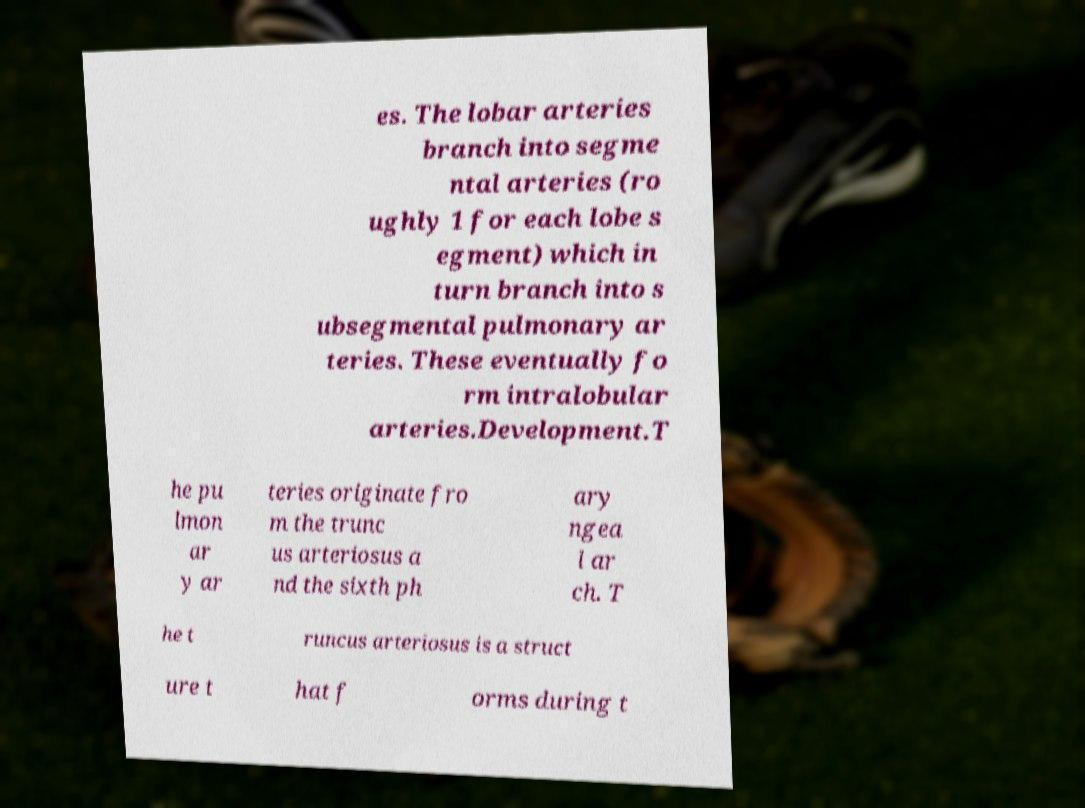Could you extract and type out the text from this image? es. The lobar arteries branch into segme ntal arteries (ro ughly 1 for each lobe s egment) which in turn branch into s ubsegmental pulmonary ar teries. These eventually fo rm intralobular arteries.Development.T he pu lmon ar y ar teries originate fro m the trunc us arteriosus a nd the sixth ph ary ngea l ar ch. T he t runcus arteriosus is a struct ure t hat f orms during t 